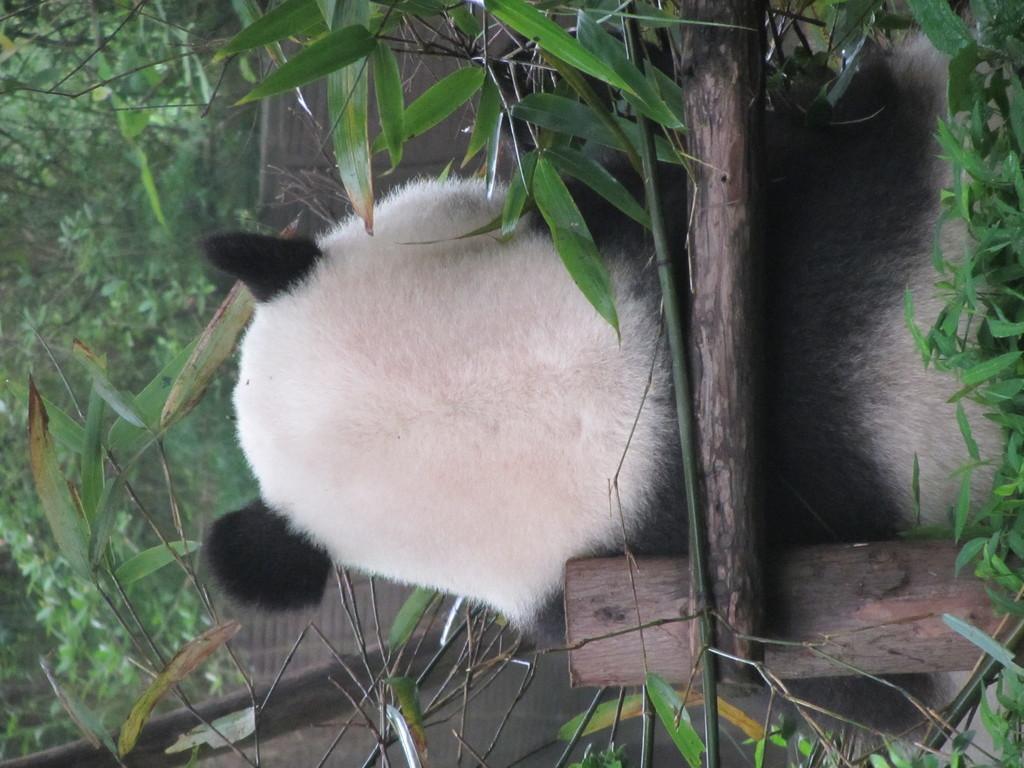Please provide a concise description of this image. On the right side corner of the image there are leaves. Behind them there are wooden poles. Behind them there is a panda sitting. And also there are leaves. In the background there are trees. 